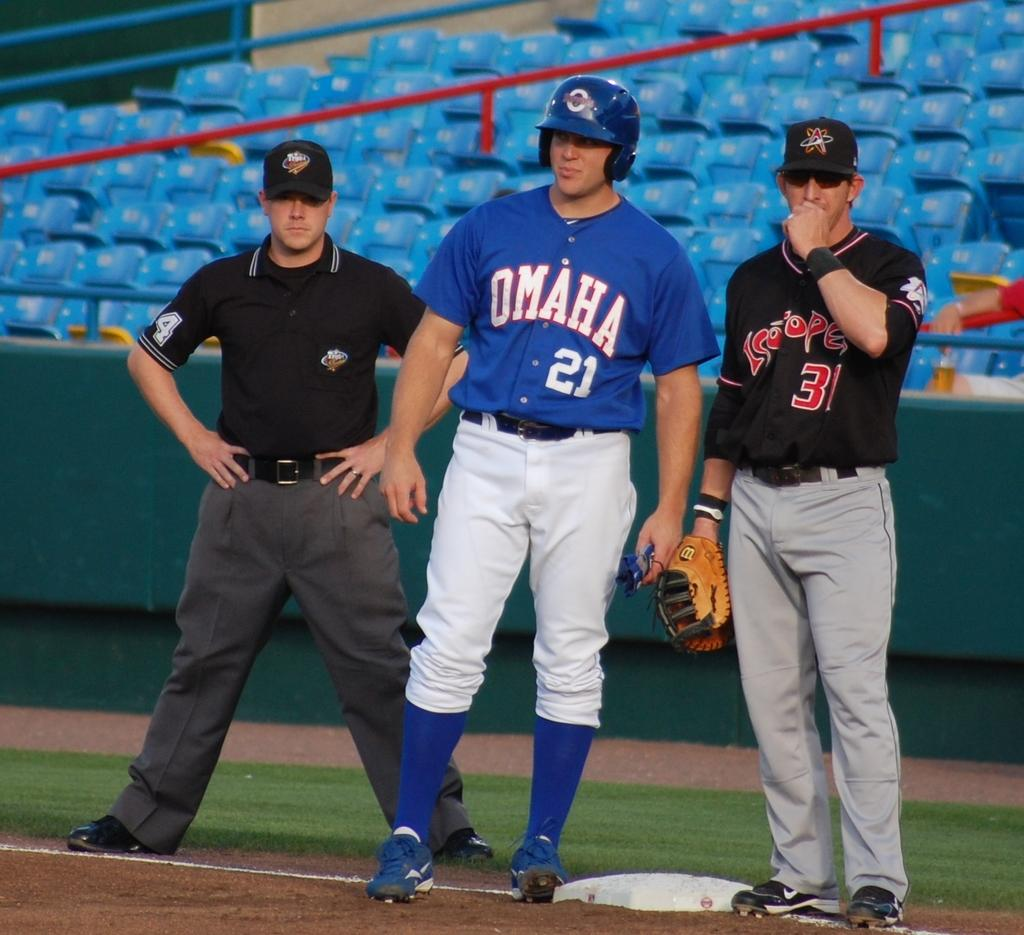<image>
Share a concise interpretation of the image provided. A group of baseball players are standing by a base and one player's shirt says Omaha. 